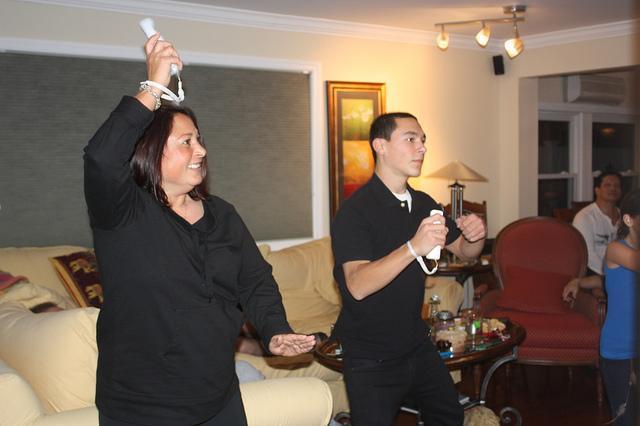How many people are playing the game?
Give a very brief answer. 2. How many people are there?
Give a very brief answer. 4. How many green cars are there?
Give a very brief answer. 0. 